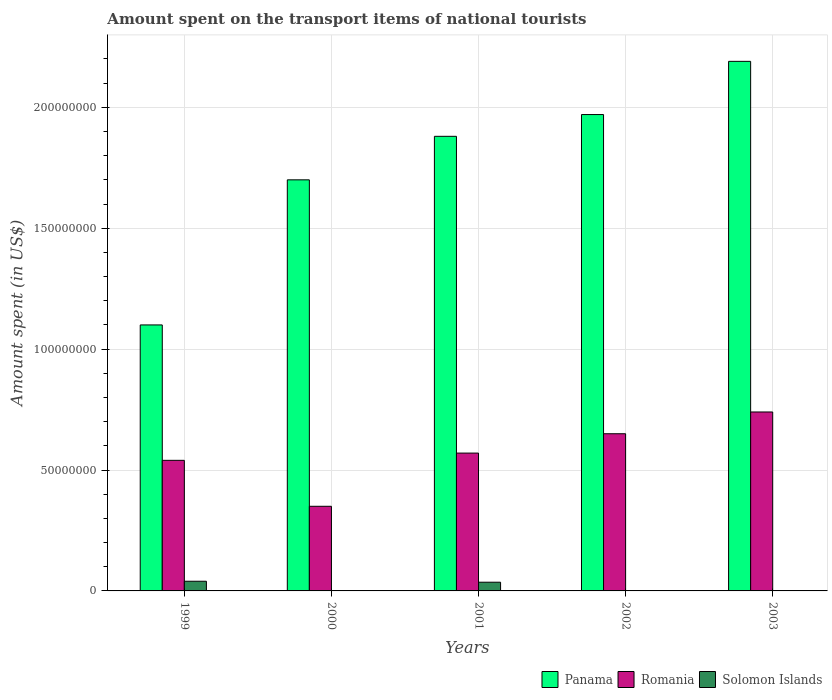How many different coloured bars are there?
Keep it short and to the point. 3. Are the number of bars per tick equal to the number of legend labels?
Your answer should be very brief. Yes. Are the number of bars on each tick of the X-axis equal?
Your answer should be very brief. Yes. What is the label of the 2nd group of bars from the left?
Ensure brevity in your answer.  2000. In how many cases, is the number of bars for a given year not equal to the number of legend labels?
Ensure brevity in your answer.  0. What is the amount spent on the transport items of national tourists in Romania in 2003?
Provide a short and direct response. 7.40e+07. Across all years, what is the maximum amount spent on the transport items of national tourists in Romania?
Your response must be concise. 7.40e+07. Across all years, what is the minimum amount spent on the transport items of national tourists in Panama?
Your response must be concise. 1.10e+08. In which year was the amount spent on the transport items of national tourists in Romania maximum?
Offer a terse response. 2003. In which year was the amount spent on the transport items of national tourists in Romania minimum?
Keep it short and to the point. 2000. What is the total amount spent on the transport items of national tourists in Solomon Islands in the graph?
Make the answer very short. 7.90e+06. What is the difference between the amount spent on the transport items of national tourists in Solomon Islands in 1999 and that in 2000?
Your answer should be very brief. 3.90e+06. What is the difference between the amount spent on the transport items of national tourists in Panama in 2000 and the amount spent on the transport items of national tourists in Romania in 2001?
Keep it short and to the point. 1.13e+08. What is the average amount spent on the transport items of national tourists in Panama per year?
Make the answer very short. 1.77e+08. In the year 2001, what is the difference between the amount spent on the transport items of national tourists in Solomon Islands and amount spent on the transport items of national tourists in Panama?
Your response must be concise. -1.84e+08. In how many years, is the amount spent on the transport items of national tourists in Romania greater than 170000000 US$?
Your answer should be compact. 0. What is the ratio of the amount spent on the transport items of national tourists in Panama in 2001 to that in 2002?
Ensure brevity in your answer.  0.95. What is the difference between the highest and the second highest amount spent on the transport items of national tourists in Panama?
Ensure brevity in your answer.  2.20e+07. What is the difference between the highest and the lowest amount spent on the transport items of national tourists in Romania?
Ensure brevity in your answer.  3.90e+07. Is the sum of the amount spent on the transport items of national tourists in Solomon Islands in 2002 and 2003 greater than the maximum amount spent on the transport items of national tourists in Panama across all years?
Offer a terse response. No. What does the 3rd bar from the left in 2003 represents?
Offer a terse response. Solomon Islands. What does the 1st bar from the right in 1999 represents?
Your answer should be very brief. Solomon Islands. How many bars are there?
Offer a very short reply. 15. How many years are there in the graph?
Make the answer very short. 5. What is the difference between two consecutive major ticks on the Y-axis?
Provide a succinct answer. 5.00e+07. Does the graph contain any zero values?
Your answer should be very brief. No. How are the legend labels stacked?
Offer a very short reply. Horizontal. What is the title of the graph?
Offer a very short reply. Amount spent on the transport items of national tourists. Does "Afghanistan" appear as one of the legend labels in the graph?
Your answer should be compact. No. What is the label or title of the X-axis?
Your answer should be very brief. Years. What is the label or title of the Y-axis?
Provide a short and direct response. Amount spent (in US$). What is the Amount spent (in US$) in Panama in 1999?
Ensure brevity in your answer.  1.10e+08. What is the Amount spent (in US$) of Romania in 1999?
Make the answer very short. 5.40e+07. What is the Amount spent (in US$) of Panama in 2000?
Ensure brevity in your answer.  1.70e+08. What is the Amount spent (in US$) of Romania in 2000?
Provide a succinct answer. 3.50e+07. What is the Amount spent (in US$) of Panama in 2001?
Keep it short and to the point. 1.88e+08. What is the Amount spent (in US$) of Romania in 2001?
Offer a very short reply. 5.70e+07. What is the Amount spent (in US$) of Solomon Islands in 2001?
Give a very brief answer. 3.60e+06. What is the Amount spent (in US$) of Panama in 2002?
Your response must be concise. 1.97e+08. What is the Amount spent (in US$) in Romania in 2002?
Give a very brief answer. 6.50e+07. What is the Amount spent (in US$) in Solomon Islands in 2002?
Provide a succinct answer. 1.00e+05. What is the Amount spent (in US$) of Panama in 2003?
Your answer should be compact. 2.19e+08. What is the Amount spent (in US$) in Romania in 2003?
Your response must be concise. 7.40e+07. What is the Amount spent (in US$) in Solomon Islands in 2003?
Make the answer very short. 1.00e+05. Across all years, what is the maximum Amount spent (in US$) in Panama?
Make the answer very short. 2.19e+08. Across all years, what is the maximum Amount spent (in US$) of Romania?
Your response must be concise. 7.40e+07. Across all years, what is the minimum Amount spent (in US$) of Panama?
Offer a terse response. 1.10e+08. Across all years, what is the minimum Amount spent (in US$) of Romania?
Your answer should be very brief. 3.50e+07. Across all years, what is the minimum Amount spent (in US$) in Solomon Islands?
Ensure brevity in your answer.  1.00e+05. What is the total Amount spent (in US$) in Panama in the graph?
Ensure brevity in your answer.  8.84e+08. What is the total Amount spent (in US$) of Romania in the graph?
Give a very brief answer. 2.85e+08. What is the total Amount spent (in US$) of Solomon Islands in the graph?
Offer a terse response. 7.90e+06. What is the difference between the Amount spent (in US$) of Panama in 1999 and that in 2000?
Give a very brief answer. -6.00e+07. What is the difference between the Amount spent (in US$) of Romania in 1999 and that in 2000?
Keep it short and to the point. 1.90e+07. What is the difference between the Amount spent (in US$) of Solomon Islands in 1999 and that in 2000?
Offer a terse response. 3.90e+06. What is the difference between the Amount spent (in US$) in Panama in 1999 and that in 2001?
Keep it short and to the point. -7.80e+07. What is the difference between the Amount spent (in US$) of Romania in 1999 and that in 2001?
Your answer should be compact. -3.00e+06. What is the difference between the Amount spent (in US$) of Solomon Islands in 1999 and that in 2001?
Make the answer very short. 4.00e+05. What is the difference between the Amount spent (in US$) of Panama in 1999 and that in 2002?
Your answer should be compact. -8.70e+07. What is the difference between the Amount spent (in US$) in Romania in 1999 and that in 2002?
Your answer should be very brief. -1.10e+07. What is the difference between the Amount spent (in US$) of Solomon Islands in 1999 and that in 2002?
Ensure brevity in your answer.  3.90e+06. What is the difference between the Amount spent (in US$) in Panama in 1999 and that in 2003?
Make the answer very short. -1.09e+08. What is the difference between the Amount spent (in US$) in Romania in 1999 and that in 2003?
Make the answer very short. -2.00e+07. What is the difference between the Amount spent (in US$) of Solomon Islands in 1999 and that in 2003?
Provide a succinct answer. 3.90e+06. What is the difference between the Amount spent (in US$) of Panama in 2000 and that in 2001?
Make the answer very short. -1.80e+07. What is the difference between the Amount spent (in US$) of Romania in 2000 and that in 2001?
Offer a terse response. -2.20e+07. What is the difference between the Amount spent (in US$) of Solomon Islands in 2000 and that in 2001?
Make the answer very short. -3.50e+06. What is the difference between the Amount spent (in US$) of Panama in 2000 and that in 2002?
Offer a very short reply. -2.70e+07. What is the difference between the Amount spent (in US$) in Romania in 2000 and that in 2002?
Offer a terse response. -3.00e+07. What is the difference between the Amount spent (in US$) in Panama in 2000 and that in 2003?
Your response must be concise. -4.90e+07. What is the difference between the Amount spent (in US$) in Romania in 2000 and that in 2003?
Your response must be concise. -3.90e+07. What is the difference between the Amount spent (in US$) of Panama in 2001 and that in 2002?
Provide a succinct answer. -9.00e+06. What is the difference between the Amount spent (in US$) in Romania in 2001 and that in 2002?
Offer a very short reply. -8.00e+06. What is the difference between the Amount spent (in US$) of Solomon Islands in 2001 and that in 2002?
Ensure brevity in your answer.  3.50e+06. What is the difference between the Amount spent (in US$) of Panama in 2001 and that in 2003?
Give a very brief answer. -3.10e+07. What is the difference between the Amount spent (in US$) of Romania in 2001 and that in 2003?
Ensure brevity in your answer.  -1.70e+07. What is the difference between the Amount spent (in US$) in Solomon Islands in 2001 and that in 2003?
Offer a terse response. 3.50e+06. What is the difference between the Amount spent (in US$) in Panama in 2002 and that in 2003?
Offer a terse response. -2.20e+07. What is the difference between the Amount spent (in US$) in Romania in 2002 and that in 2003?
Ensure brevity in your answer.  -9.00e+06. What is the difference between the Amount spent (in US$) of Solomon Islands in 2002 and that in 2003?
Offer a terse response. 0. What is the difference between the Amount spent (in US$) in Panama in 1999 and the Amount spent (in US$) in Romania in 2000?
Ensure brevity in your answer.  7.50e+07. What is the difference between the Amount spent (in US$) in Panama in 1999 and the Amount spent (in US$) in Solomon Islands in 2000?
Make the answer very short. 1.10e+08. What is the difference between the Amount spent (in US$) of Romania in 1999 and the Amount spent (in US$) of Solomon Islands in 2000?
Your answer should be very brief. 5.39e+07. What is the difference between the Amount spent (in US$) of Panama in 1999 and the Amount spent (in US$) of Romania in 2001?
Keep it short and to the point. 5.30e+07. What is the difference between the Amount spent (in US$) in Panama in 1999 and the Amount spent (in US$) in Solomon Islands in 2001?
Offer a very short reply. 1.06e+08. What is the difference between the Amount spent (in US$) in Romania in 1999 and the Amount spent (in US$) in Solomon Islands in 2001?
Give a very brief answer. 5.04e+07. What is the difference between the Amount spent (in US$) in Panama in 1999 and the Amount spent (in US$) in Romania in 2002?
Offer a terse response. 4.50e+07. What is the difference between the Amount spent (in US$) of Panama in 1999 and the Amount spent (in US$) of Solomon Islands in 2002?
Offer a terse response. 1.10e+08. What is the difference between the Amount spent (in US$) in Romania in 1999 and the Amount spent (in US$) in Solomon Islands in 2002?
Provide a succinct answer. 5.39e+07. What is the difference between the Amount spent (in US$) in Panama in 1999 and the Amount spent (in US$) in Romania in 2003?
Keep it short and to the point. 3.60e+07. What is the difference between the Amount spent (in US$) of Panama in 1999 and the Amount spent (in US$) of Solomon Islands in 2003?
Your answer should be compact. 1.10e+08. What is the difference between the Amount spent (in US$) in Romania in 1999 and the Amount spent (in US$) in Solomon Islands in 2003?
Your answer should be compact. 5.39e+07. What is the difference between the Amount spent (in US$) in Panama in 2000 and the Amount spent (in US$) in Romania in 2001?
Offer a very short reply. 1.13e+08. What is the difference between the Amount spent (in US$) in Panama in 2000 and the Amount spent (in US$) in Solomon Islands in 2001?
Make the answer very short. 1.66e+08. What is the difference between the Amount spent (in US$) of Romania in 2000 and the Amount spent (in US$) of Solomon Islands in 2001?
Offer a terse response. 3.14e+07. What is the difference between the Amount spent (in US$) of Panama in 2000 and the Amount spent (in US$) of Romania in 2002?
Provide a succinct answer. 1.05e+08. What is the difference between the Amount spent (in US$) of Panama in 2000 and the Amount spent (in US$) of Solomon Islands in 2002?
Make the answer very short. 1.70e+08. What is the difference between the Amount spent (in US$) in Romania in 2000 and the Amount spent (in US$) in Solomon Islands in 2002?
Your answer should be very brief. 3.49e+07. What is the difference between the Amount spent (in US$) of Panama in 2000 and the Amount spent (in US$) of Romania in 2003?
Your answer should be very brief. 9.60e+07. What is the difference between the Amount spent (in US$) in Panama in 2000 and the Amount spent (in US$) in Solomon Islands in 2003?
Your answer should be compact. 1.70e+08. What is the difference between the Amount spent (in US$) of Romania in 2000 and the Amount spent (in US$) of Solomon Islands in 2003?
Your answer should be compact. 3.49e+07. What is the difference between the Amount spent (in US$) in Panama in 2001 and the Amount spent (in US$) in Romania in 2002?
Your answer should be compact. 1.23e+08. What is the difference between the Amount spent (in US$) in Panama in 2001 and the Amount spent (in US$) in Solomon Islands in 2002?
Provide a succinct answer. 1.88e+08. What is the difference between the Amount spent (in US$) of Romania in 2001 and the Amount spent (in US$) of Solomon Islands in 2002?
Your response must be concise. 5.69e+07. What is the difference between the Amount spent (in US$) in Panama in 2001 and the Amount spent (in US$) in Romania in 2003?
Your response must be concise. 1.14e+08. What is the difference between the Amount spent (in US$) of Panama in 2001 and the Amount spent (in US$) of Solomon Islands in 2003?
Your answer should be very brief. 1.88e+08. What is the difference between the Amount spent (in US$) in Romania in 2001 and the Amount spent (in US$) in Solomon Islands in 2003?
Offer a very short reply. 5.69e+07. What is the difference between the Amount spent (in US$) of Panama in 2002 and the Amount spent (in US$) of Romania in 2003?
Make the answer very short. 1.23e+08. What is the difference between the Amount spent (in US$) of Panama in 2002 and the Amount spent (in US$) of Solomon Islands in 2003?
Offer a terse response. 1.97e+08. What is the difference between the Amount spent (in US$) of Romania in 2002 and the Amount spent (in US$) of Solomon Islands in 2003?
Provide a succinct answer. 6.49e+07. What is the average Amount spent (in US$) of Panama per year?
Offer a terse response. 1.77e+08. What is the average Amount spent (in US$) in Romania per year?
Make the answer very short. 5.70e+07. What is the average Amount spent (in US$) of Solomon Islands per year?
Provide a succinct answer. 1.58e+06. In the year 1999, what is the difference between the Amount spent (in US$) of Panama and Amount spent (in US$) of Romania?
Your response must be concise. 5.60e+07. In the year 1999, what is the difference between the Amount spent (in US$) of Panama and Amount spent (in US$) of Solomon Islands?
Offer a very short reply. 1.06e+08. In the year 2000, what is the difference between the Amount spent (in US$) of Panama and Amount spent (in US$) of Romania?
Offer a terse response. 1.35e+08. In the year 2000, what is the difference between the Amount spent (in US$) of Panama and Amount spent (in US$) of Solomon Islands?
Provide a short and direct response. 1.70e+08. In the year 2000, what is the difference between the Amount spent (in US$) of Romania and Amount spent (in US$) of Solomon Islands?
Give a very brief answer. 3.49e+07. In the year 2001, what is the difference between the Amount spent (in US$) in Panama and Amount spent (in US$) in Romania?
Ensure brevity in your answer.  1.31e+08. In the year 2001, what is the difference between the Amount spent (in US$) of Panama and Amount spent (in US$) of Solomon Islands?
Your response must be concise. 1.84e+08. In the year 2001, what is the difference between the Amount spent (in US$) of Romania and Amount spent (in US$) of Solomon Islands?
Provide a short and direct response. 5.34e+07. In the year 2002, what is the difference between the Amount spent (in US$) of Panama and Amount spent (in US$) of Romania?
Your answer should be very brief. 1.32e+08. In the year 2002, what is the difference between the Amount spent (in US$) in Panama and Amount spent (in US$) in Solomon Islands?
Your answer should be very brief. 1.97e+08. In the year 2002, what is the difference between the Amount spent (in US$) of Romania and Amount spent (in US$) of Solomon Islands?
Provide a succinct answer. 6.49e+07. In the year 2003, what is the difference between the Amount spent (in US$) in Panama and Amount spent (in US$) in Romania?
Provide a short and direct response. 1.45e+08. In the year 2003, what is the difference between the Amount spent (in US$) of Panama and Amount spent (in US$) of Solomon Islands?
Give a very brief answer. 2.19e+08. In the year 2003, what is the difference between the Amount spent (in US$) in Romania and Amount spent (in US$) in Solomon Islands?
Offer a very short reply. 7.39e+07. What is the ratio of the Amount spent (in US$) of Panama in 1999 to that in 2000?
Give a very brief answer. 0.65. What is the ratio of the Amount spent (in US$) of Romania in 1999 to that in 2000?
Make the answer very short. 1.54. What is the ratio of the Amount spent (in US$) in Solomon Islands in 1999 to that in 2000?
Offer a terse response. 40. What is the ratio of the Amount spent (in US$) of Panama in 1999 to that in 2001?
Keep it short and to the point. 0.59. What is the ratio of the Amount spent (in US$) of Romania in 1999 to that in 2001?
Ensure brevity in your answer.  0.95. What is the ratio of the Amount spent (in US$) of Solomon Islands in 1999 to that in 2001?
Give a very brief answer. 1.11. What is the ratio of the Amount spent (in US$) of Panama in 1999 to that in 2002?
Provide a succinct answer. 0.56. What is the ratio of the Amount spent (in US$) in Romania in 1999 to that in 2002?
Your response must be concise. 0.83. What is the ratio of the Amount spent (in US$) in Panama in 1999 to that in 2003?
Offer a terse response. 0.5. What is the ratio of the Amount spent (in US$) in Romania in 1999 to that in 2003?
Offer a very short reply. 0.73. What is the ratio of the Amount spent (in US$) in Panama in 2000 to that in 2001?
Your response must be concise. 0.9. What is the ratio of the Amount spent (in US$) in Romania in 2000 to that in 2001?
Your answer should be very brief. 0.61. What is the ratio of the Amount spent (in US$) of Solomon Islands in 2000 to that in 2001?
Offer a terse response. 0.03. What is the ratio of the Amount spent (in US$) in Panama in 2000 to that in 2002?
Ensure brevity in your answer.  0.86. What is the ratio of the Amount spent (in US$) in Romania in 2000 to that in 2002?
Your answer should be compact. 0.54. What is the ratio of the Amount spent (in US$) of Solomon Islands in 2000 to that in 2002?
Give a very brief answer. 1. What is the ratio of the Amount spent (in US$) in Panama in 2000 to that in 2003?
Make the answer very short. 0.78. What is the ratio of the Amount spent (in US$) in Romania in 2000 to that in 2003?
Ensure brevity in your answer.  0.47. What is the ratio of the Amount spent (in US$) of Solomon Islands in 2000 to that in 2003?
Provide a succinct answer. 1. What is the ratio of the Amount spent (in US$) in Panama in 2001 to that in 2002?
Give a very brief answer. 0.95. What is the ratio of the Amount spent (in US$) of Romania in 2001 to that in 2002?
Your answer should be compact. 0.88. What is the ratio of the Amount spent (in US$) in Solomon Islands in 2001 to that in 2002?
Provide a short and direct response. 36. What is the ratio of the Amount spent (in US$) of Panama in 2001 to that in 2003?
Provide a succinct answer. 0.86. What is the ratio of the Amount spent (in US$) in Romania in 2001 to that in 2003?
Offer a very short reply. 0.77. What is the ratio of the Amount spent (in US$) in Solomon Islands in 2001 to that in 2003?
Provide a succinct answer. 36. What is the ratio of the Amount spent (in US$) of Panama in 2002 to that in 2003?
Provide a succinct answer. 0.9. What is the ratio of the Amount spent (in US$) in Romania in 2002 to that in 2003?
Provide a succinct answer. 0.88. What is the difference between the highest and the second highest Amount spent (in US$) in Panama?
Provide a succinct answer. 2.20e+07. What is the difference between the highest and the second highest Amount spent (in US$) in Romania?
Keep it short and to the point. 9.00e+06. What is the difference between the highest and the lowest Amount spent (in US$) in Panama?
Keep it short and to the point. 1.09e+08. What is the difference between the highest and the lowest Amount spent (in US$) of Romania?
Offer a very short reply. 3.90e+07. What is the difference between the highest and the lowest Amount spent (in US$) of Solomon Islands?
Provide a short and direct response. 3.90e+06. 